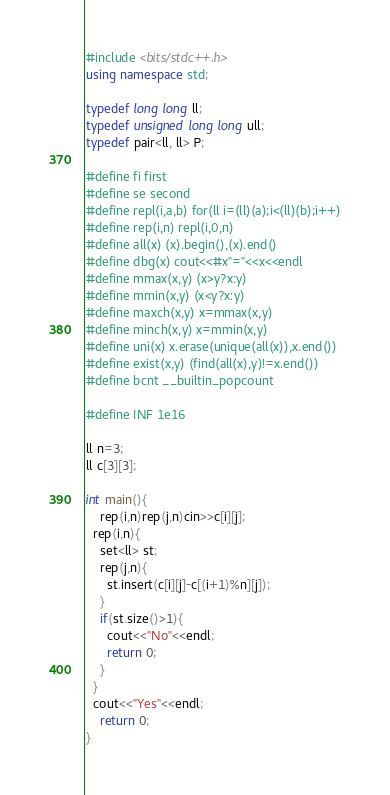Convert code to text. <code><loc_0><loc_0><loc_500><loc_500><_C++_>#include <bits/stdc++.h>
using namespace std;

typedef long long ll;
typedef unsigned long long ull;
typedef pair<ll, ll> P;

#define fi first
#define se second
#define repl(i,a,b) for(ll i=(ll)(a);i<(ll)(b);i++)
#define rep(i,n) repl(i,0,n)
#define all(x) (x).begin(),(x).end()
#define dbg(x) cout<<#x"="<<x<<endl
#define mmax(x,y) (x>y?x:y)
#define mmin(x,y) (x<y?x:y)
#define maxch(x,y) x=mmax(x,y)
#define minch(x,y) x=mmin(x,y)
#define uni(x) x.erase(unique(all(x)),x.end())
#define exist(x,y) (find(all(x),y)!=x.end())
#define bcnt __builtin_popcount

#define INF 1e16

ll n=3;
ll c[3][3];

int main(){
	rep(i,n)rep(j,n)cin>>c[i][j];
  rep(i,n){
    set<ll> st;
    rep(j,n){
      st.insert(c[i][j]-c[(i+1)%n][j]);
    }
    if(st.size()>1){
      cout<<"No"<<endl;
      return 0;
    }
  }
  cout<<"Yes"<<endl;
	return 0;
}
</code> 